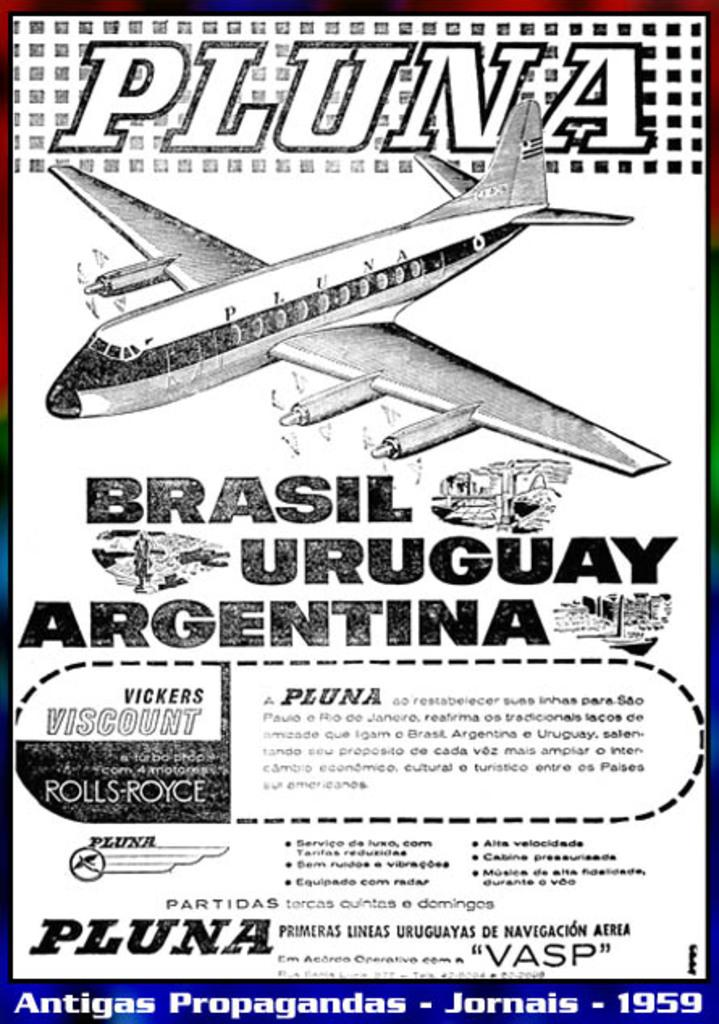<image>
Provide a brief description of the given image. An ad for Pluna which travels to Brasil, Uruguay and Argentina. 